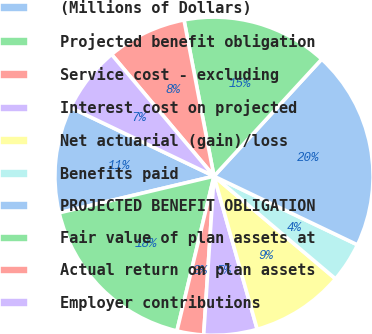<chart> <loc_0><loc_0><loc_500><loc_500><pie_chart><fcel>(Millions of Dollars)<fcel>Projected benefit obligation<fcel>Service cost - excluding<fcel>Interest cost on projected<fcel>Net actuarial (gain)/loss<fcel>Benefits paid<fcel>PROJECTED BENEFIT OBLIGATION<fcel>Fair value of plan assets at<fcel>Actual return on plan assets<fcel>Employer contributions<nl><fcel>10.81%<fcel>17.56%<fcel>2.71%<fcel>5.41%<fcel>9.46%<fcel>4.06%<fcel>20.26%<fcel>14.86%<fcel>8.11%<fcel>6.76%<nl></chart> 